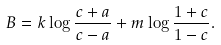Convert formula to latex. <formula><loc_0><loc_0><loc_500><loc_500>B = k \log \frac { c + a } { c - a } + m \log \frac { 1 + c } { 1 - c } .</formula> 